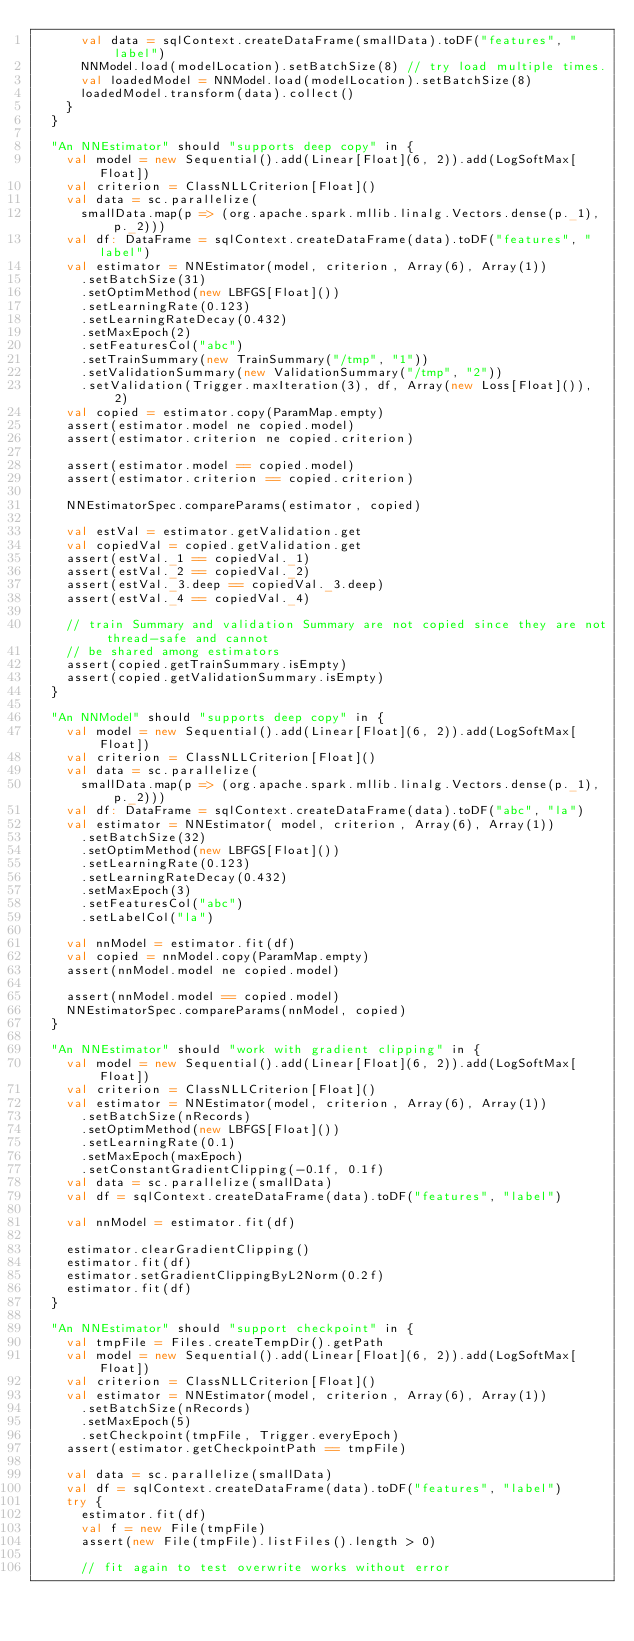<code> <loc_0><loc_0><loc_500><loc_500><_Scala_>      val data = sqlContext.createDataFrame(smallData).toDF("features", "label")
      NNModel.load(modelLocation).setBatchSize(8) // try load multiple times.
      val loadedModel = NNModel.load(modelLocation).setBatchSize(8)
      loadedModel.transform(data).collect()
    }
  }

  "An NNEstimator" should "supports deep copy" in {
    val model = new Sequential().add(Linear[Float](6, 2)).add(LogSoftMax[Float])
    val criterion = ClassNLLCriterion[Float]()
    val data = sc.parallelize(
      smallData.map(p => (org.apache.spark.mllib.linalg.Vectors.dense(p._1), p._2)))
    val df: DataFrame = sqlContext.createDataFrame(data).toDF("features", "label")
    val estimator = NNEstimator(model, criterion, Array(6), Array(1))
      .setBatchSize(31)
      .setOptimMethod(new LBFGS[Float]())
      .setLearningRate(0.123)
      .setLearningRateDecay(0.432)
      .setMaxEpoch(2)
      .setFeaturesCol("abc")
      .setTrainSummary(new TrainSummary("/tmp", "1"))
      .setValidationSummary(new ValidationSummary("/tmp", "2"))
      .setValidation(Trigger.maxIteration(3), df, Array(new Loss[Float]()), 2)
    val copied = estimator.copy(ParamMap.empty)
    assert(estimator.model ne copied.model)
    assert(estimator.criterion ne copied.criterion)

    assert(estimator.model == copied.model)
    assert(estimator.criterion == copied.criterion)

    NNEstimatorSpec.compareParams(estimator, copied)

    val estVal = estimator.getValidation.get
    val copiedVal = copied.getValidation.get
    assert(estVal._1 == copiedVal._1)
    assert(estVal._2 == copiedVal._2)
    assert(estVal._3.deep == copiedVal._3.deep)
    assert(estVal._4 == copiedVal._4)

    // train Summary and validation Summary are not copied since they are not thread-safe and cannot
    // be shared among estimators
    assert(copied.getTrainSummary.isEmpty)
    assert(copied.getValidationSummary.isEmpty)
  }

  "An NNModel" should "supports deep copy" in {
    val model = new Sequential().add(Linear[Float](6, 2)).add(LogSoftMax[Float])
    val criterion = ClassNLLCriterion[Float]()
    val data = sc.parallelize(
      smallData.map(p => (org.apache.spark.mllib.linalg.Vectors.dense(p._1), p._2)))
    val df: DataFrame = sqlContext.createDataFrame(data).toDF("abc", "la")
    val estimator = NNEstimator( model, criterion, Array(6), Array(1))
      .setBatchSize(32)
      .setOptimMethod(new LBFGS[Float]())
      .setLearningRate(0.123)
      .setLearningRateDecay(0.432)
      .setMaxEpoch(3)
      .setFeaturesCol("abc")
      .setLabelCol("la")

    val nnModel = estimator.fit(df)
    val copied = nnModel.copy(ParamMap.empty)
    assert(nnModel.model ne copied.model)

    assert(nnModel.model == copied.model)
    NNEstimatorSpec.compareParams(nnModel, copied)
  }

  "An NNEstimator" should "work with gradient clipping" in {
    val model = new Sequential().add(Linear[Float](6, 2)).add(LogSoftMax[Float])
    val criterion = ClassNLLCriterion[Float]()
    val estimator = NNEstimator(model, criterion, Array(6), Array(1))
      .setBatchSize(nRecords)
      .setOptimMethod(new LBFGS[Float]())
      .setLearningRate(0.1)
      .setMaxEpoch(maxEpoch)
      .setConstantGradientClipping(-0.1f, 0.1f)
    val data = sc.parallelize(smallData)
    val df = sqlContext.createDataFrame(data).toDF("features", "label")

    val nnModel = estimator.fit(df)

    estimator.clearGradientClipping()
    estimator.fit(df)
    estimator.setGradientClippingByL2Norm(0.2f)
    estimator.fit(df)
  }

  "An NNEstimator" should "support checkpoint" in {
    val tmpFile = Files.createTempDir().getPath
    val model = new Sequential().add(Linear[Float](6, 2)).add(LogSoftMax[Float])
    val criterion = ClassNLLCriterion[Float]()
    val estimator = NNEstimator(model, criterion, Array(6), Array(1))
      .setBatchSize(nRecords)
      .setMaxEpoch(5)
      .setCheckpoint(tmpFile, Trigger.everyEpoch)
    assert(estimator.getCheckpointPath == tmpFile)

    val data = sc.parallelize(smallData)
    val df = sqlContext.createDataFrame(data).toDF("features", "label")
    try {
      estimator.fit(df)
      val f = new File(tmpFile)
      assert(new File(tmpFile).listFiles().length > 0)

      // fit again to test overwrite works without error</code> 